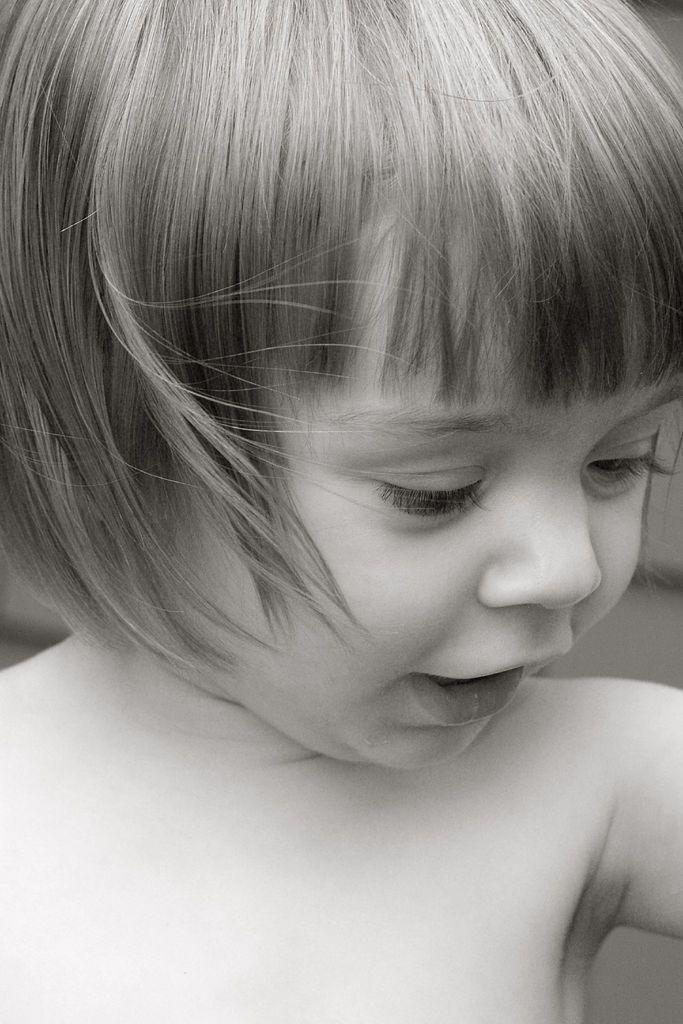What is the main subject of the image? There is a beautiful girl in the image. What is the girl doing in the image? The girl is talking. What is the color scheme of the image? The image is in black and white. What type of crayon is the girl using to draw in the image? There is no crayon or drawing activity present in the image. What emotion might the girl be feeling based on her facial expression in the image? The image is in black and white, so it is difficult to determine the girl's exact emotion from her facial expression. 